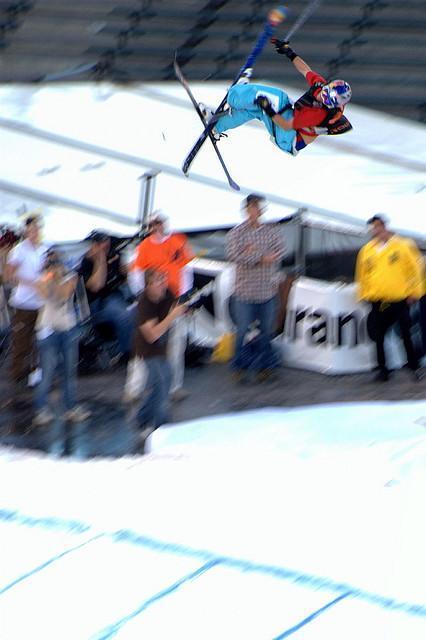How many people are visible?
Give a very brief answer. 8. How many ski are there?
Give a very brief answer. 1. How many red buses are there?
Give a very brief answer. 0. 